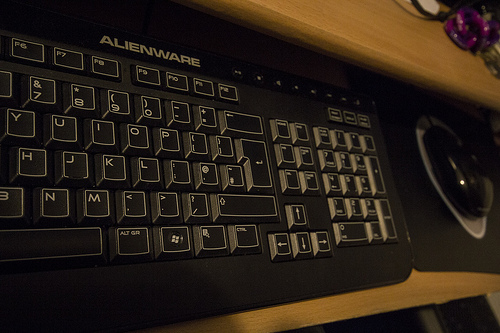Which kind of furniture is it? The correct term for the furniture in the image is a desk, which is meant to accommodate computer peripherals and offer a stable work surface. 